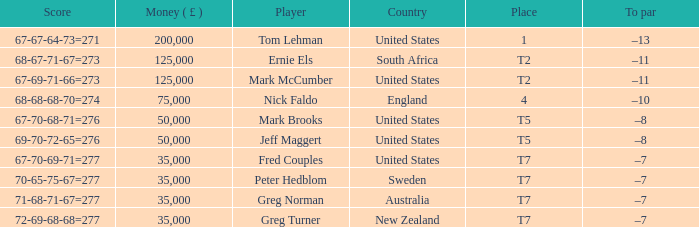What is To par, when Country is "United States", when Money ( £ ) is greater than 125,000, and when Score is "67-70-68-71=276"? None. 